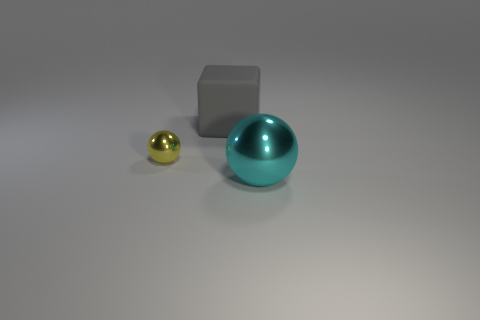What shape is the metal thing on the left side of the cyan ball?
Your response must be concise. Sphere. What number of metal things are to the left of the cyan thing and right of the yellow object?
Provide a short and direct response. 0. Does the yellow metal object have the same size as the shiny sphere that is right of the gray block?
Make the answer very short. No. What is the size of the object that is on the left side of the big thing to the left of the large object that is in front of the large matte block?
Provide a short and direct response. Small. What size is the metal sphere behind the cyan metallic sphere?
Ensure brevity in your answer.  Small. What shape is the other large object that is the same material as the yellow thing?
Your response must be concise. Sphere. Are the ball behind the cyan ball and the gray thing made of the same material?
Ensure brevity in your answer.  No. What number of other objects are the same material as the big gray cube?
Your response must be concise. 0. What number of objects are either metallic balls to the right of the yellow ball or objects that are in front of the yellow shiny thing?
Provide a short and direct response. 1. There is a thing that is in front of the yellow metallic sphere; does it have the same shape as the metal thing that is to the left of the big ball?
Offer a terse response. Yes. 